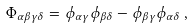Convert formula to latex. <formula><loc_0><loc_0><loc_500><loc_500>\Phi _ { \alpha \beta \gamma \delta } = \phi _ { \alpha \gamma } \phi _ { \beta \delta } - \phi _ { \beta \gamma } \phi _ { \alpha \delta } \, ,</formula> 